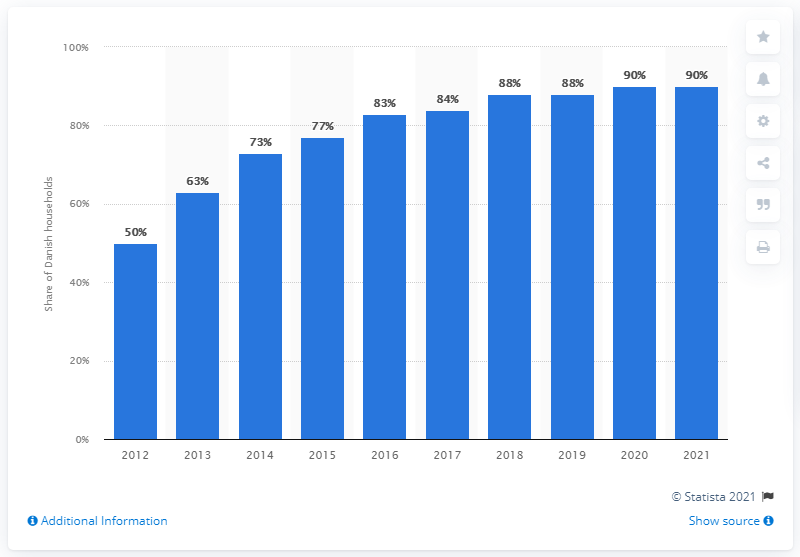Draw attention to some important aspects in this diagram. In 2012, approximately 50% of Danish households owned a smartphone. According to a recent survey, in 2021, approximately 90% of Danish households owned at least one smartphone. 